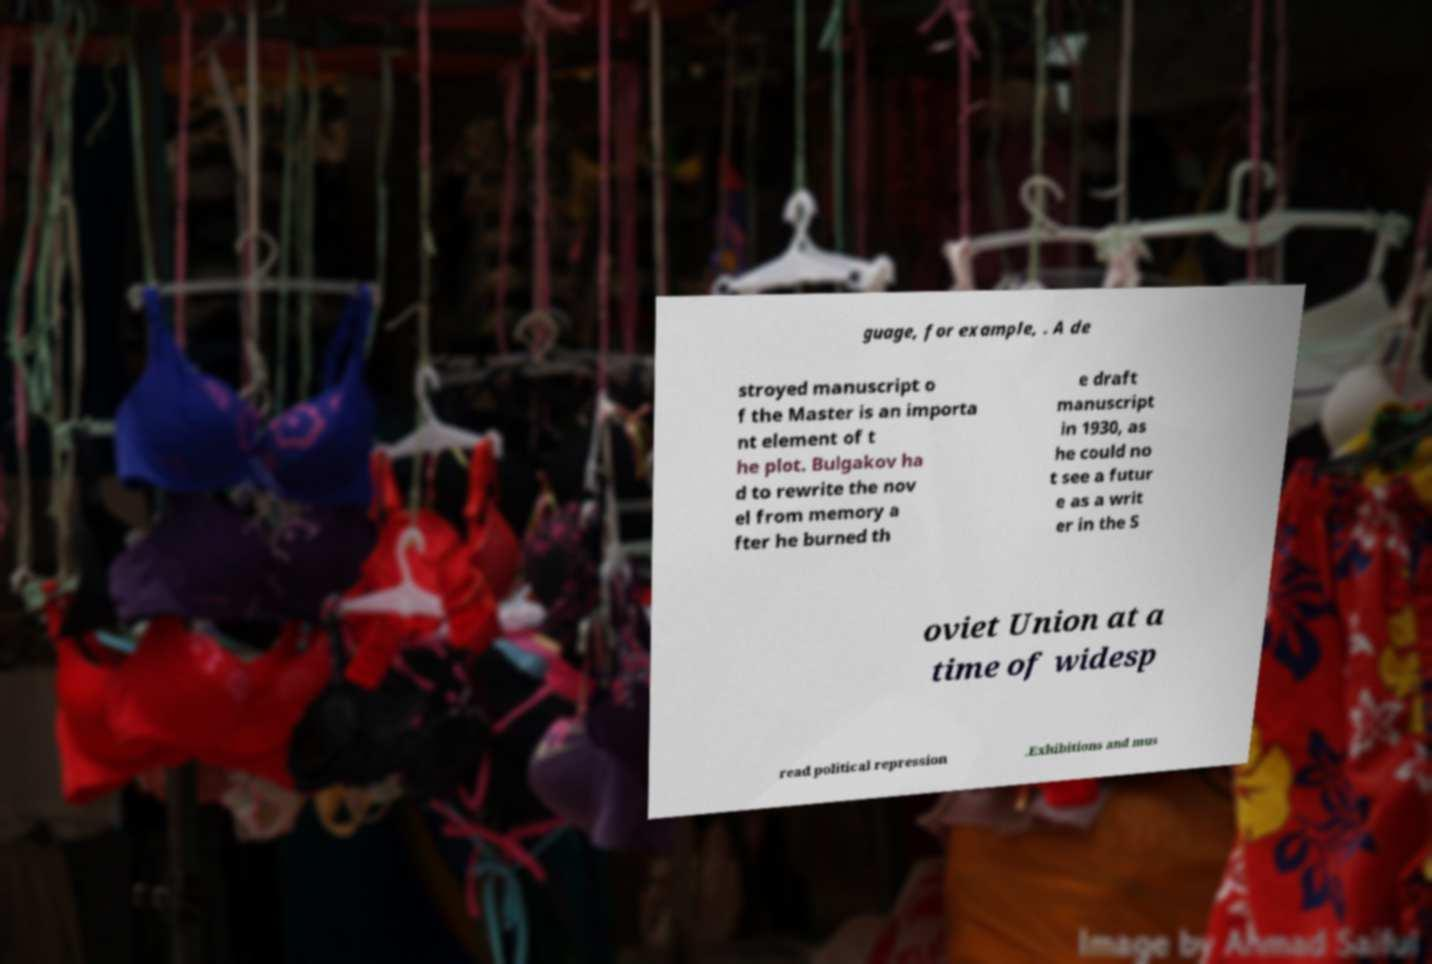I need the written content from this picture converted into text. Can you do that? guage, for example, . A de stroyed manuscript o f the Master is an importa nt element of t he plot. Bulgakov ha d to rewrite the nov el from memory a fter he burned th e draft manuscript in 1930, as he could no t see a futur e as a writ er in the S oviet Union at a time of widesp read political repression .Exhibitions and mus 